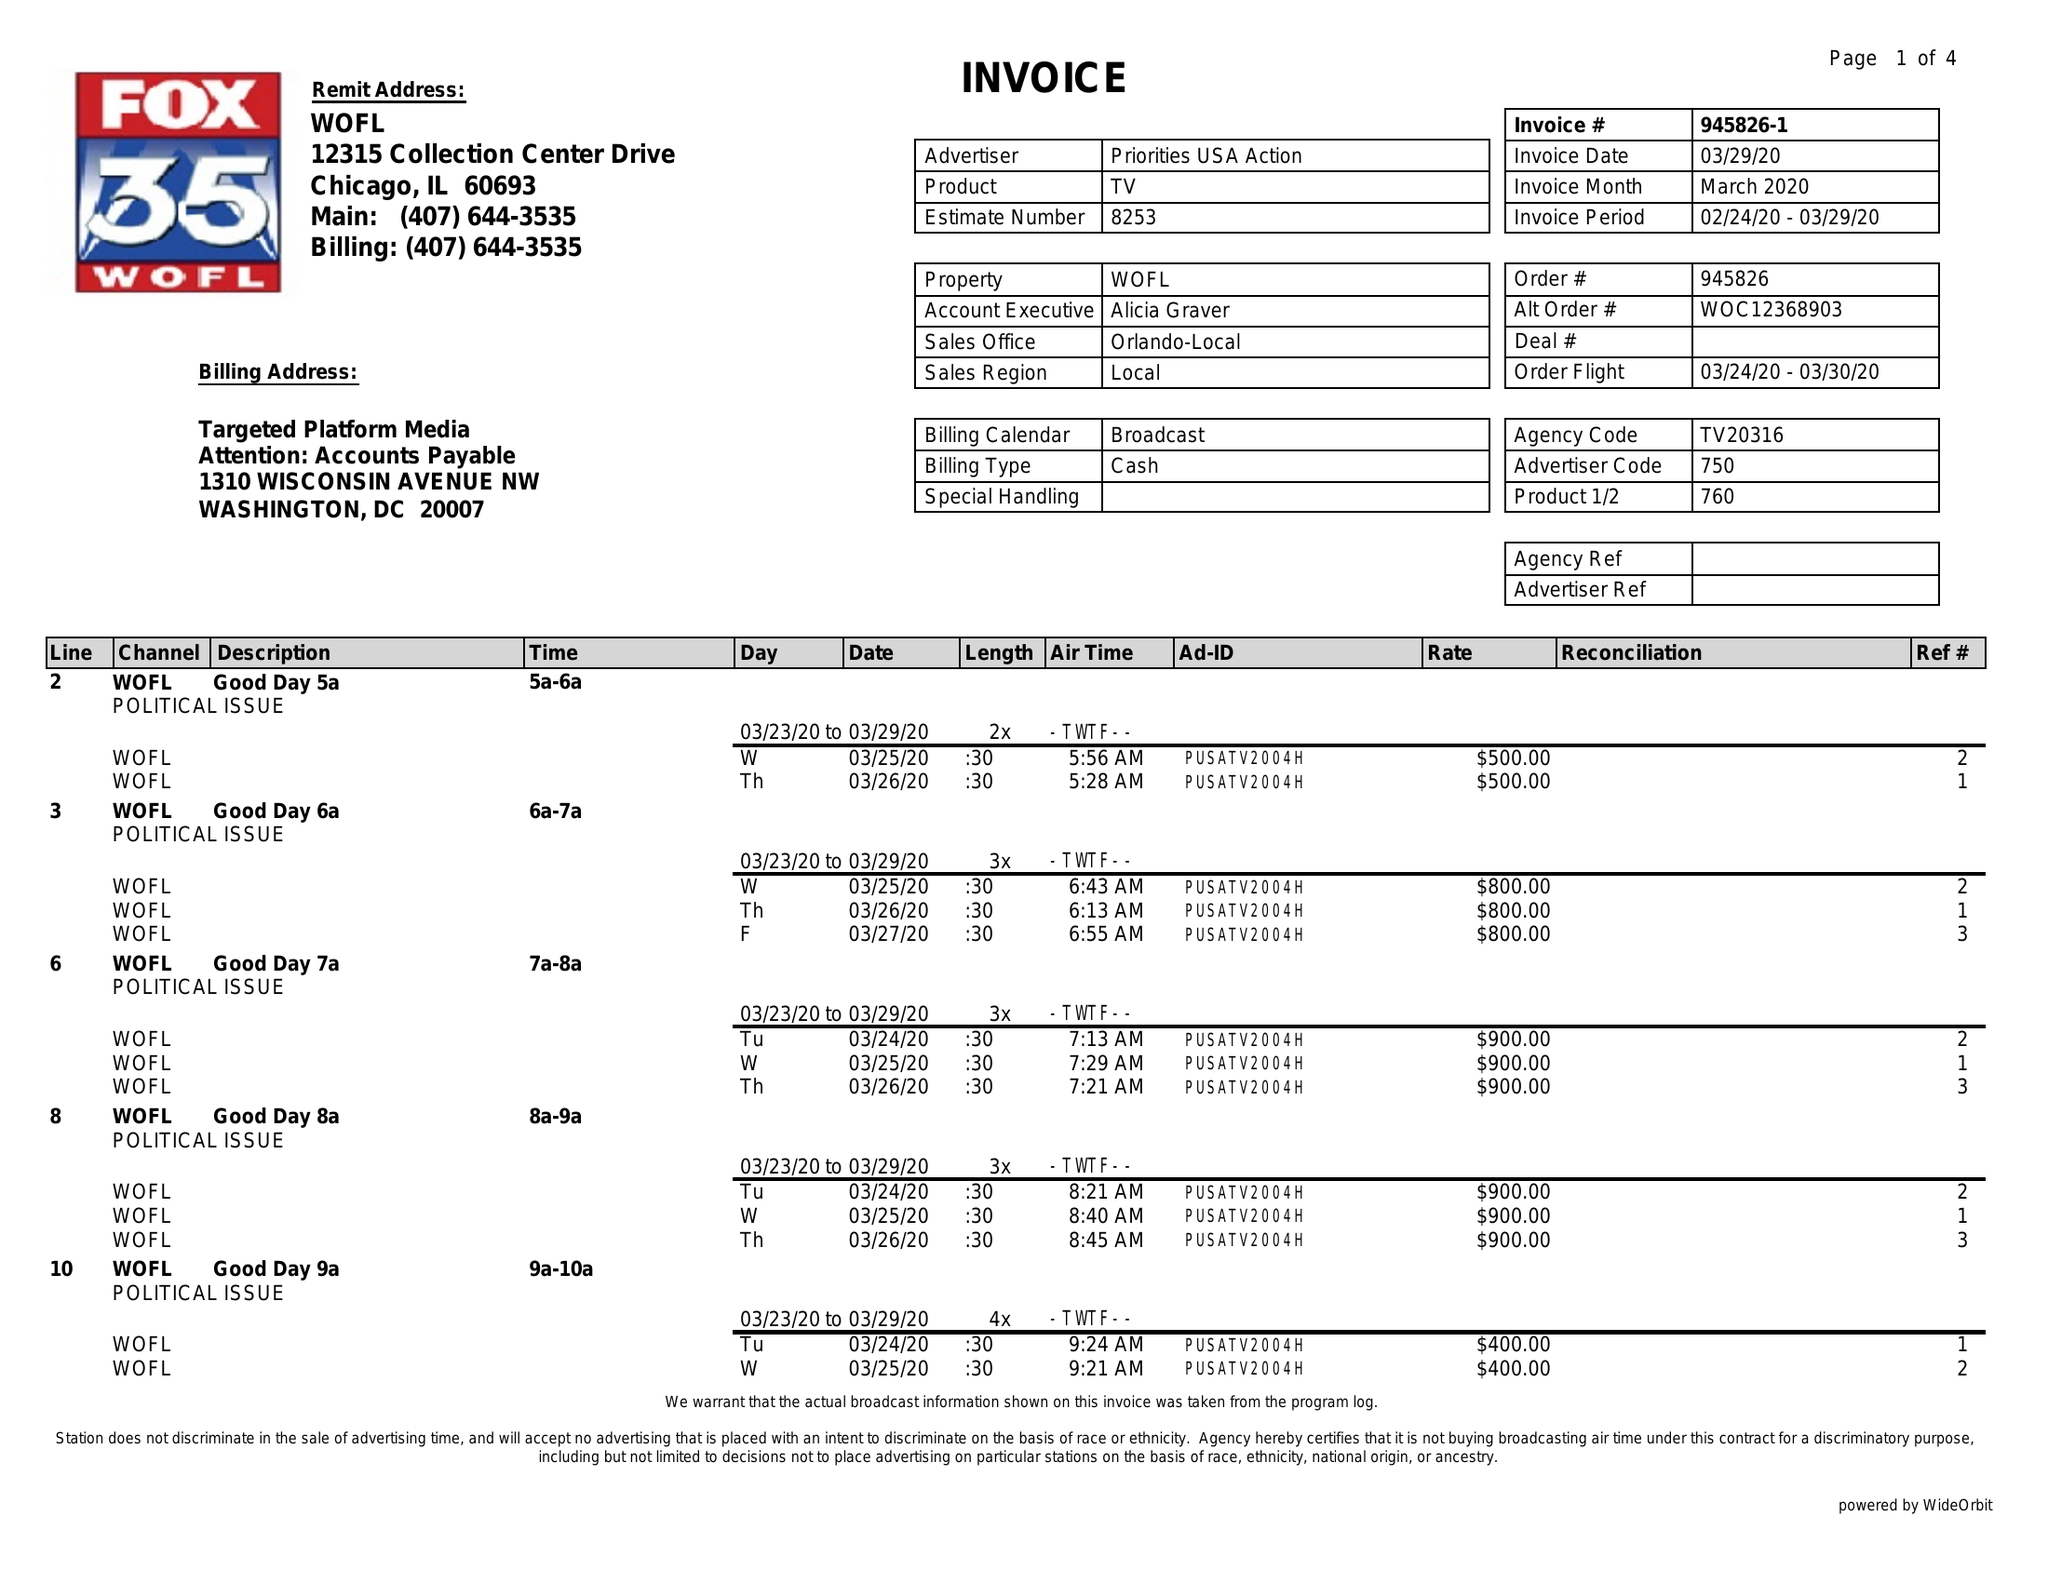What is the value for the contract_num?
Answer the question using a single word or phrase. 945826 